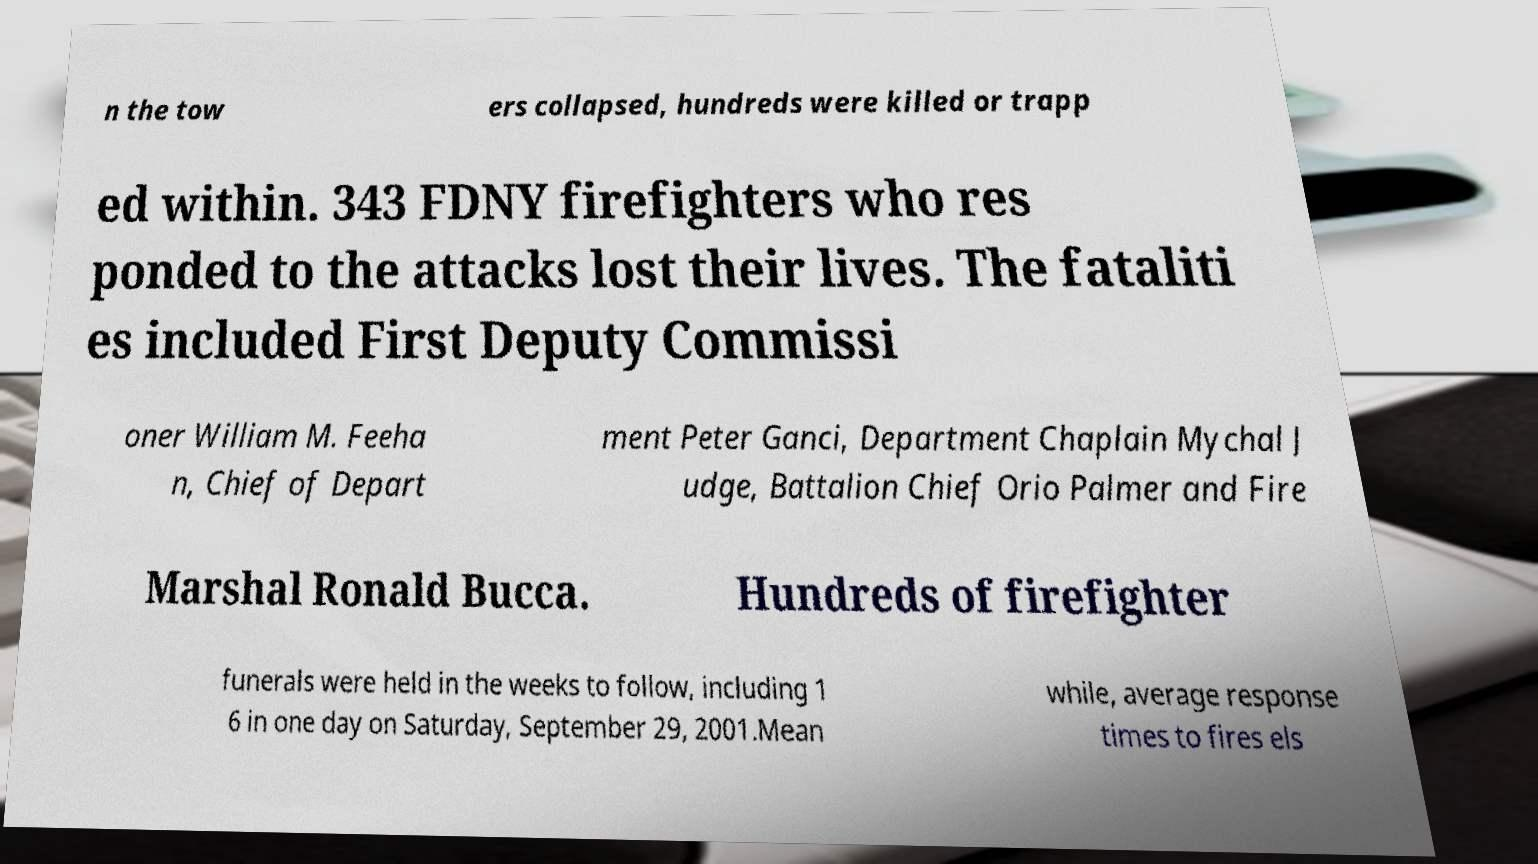I need the written content from this picture converted into text. Can you do that? n the tow ers collapsed, hundreds were killed or trapp ed within. 343 FDNY firefighters who res ponded to the attacks lost their lives. The fataliti es included First Deputy Commissi oner William M. Feeha n, Chief of Depart ment Peter Ganci, Department Chaplain Mychal J udge, Battalion Chief Orio Palmer and Fire Marshal Ronald Bucca. Hundreds of firefighter funerals were held in the weeks to follow, including 1 6 in one day on Saturday, September 29, 2001.Mean while, average response times to fires els 